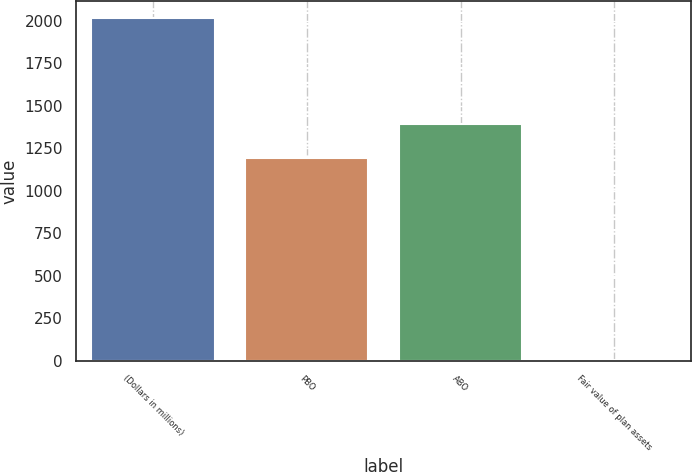Convert chart. <chart><loc_0><loc_0><loc_500><loc_500><bar_chart><fcel>(Dollars in millions)<fcel>PBO<fcel>ABO<fcel>Fair value of plan assets<nl><fcel>2014<fcel>1190<fcel>1391.2<fcel>2<nl></chart> 